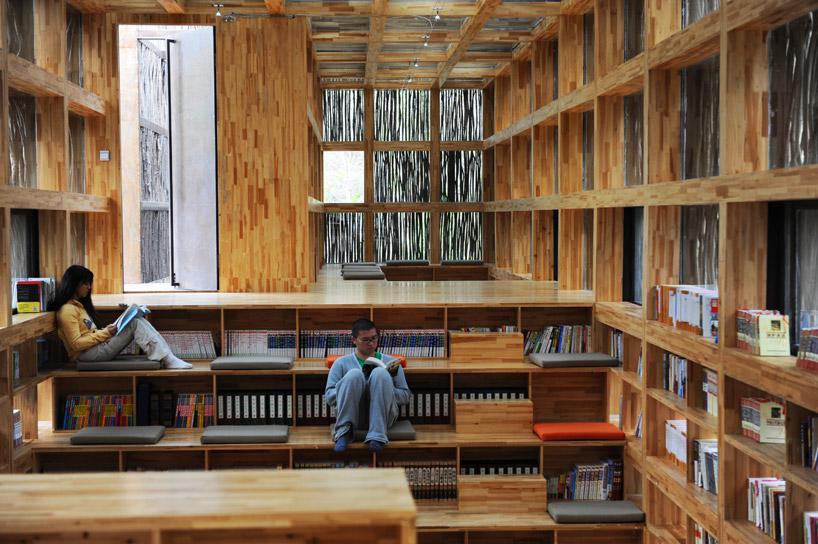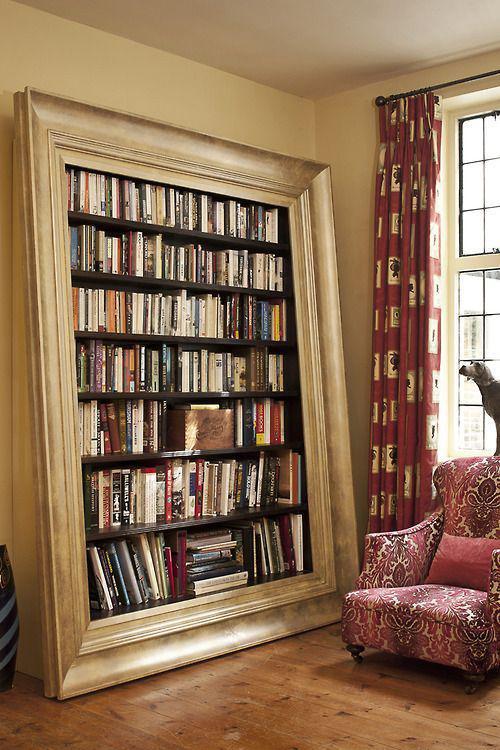The first image is the image on the left, the second image is the image on the right. Evaluate the accuracy of this statement regarding the images: "In one image, bookcases along a wall flank a fireplace, over which hangs one framed picture.". Is it true? Answer yes or no. No. The first image is the image on the left, the second image is the image on the right. Assess this claim about the two images: "A window is visible behind a seating that is near to a bookcase.". Correct or not? Answer yes or no. Yes. 